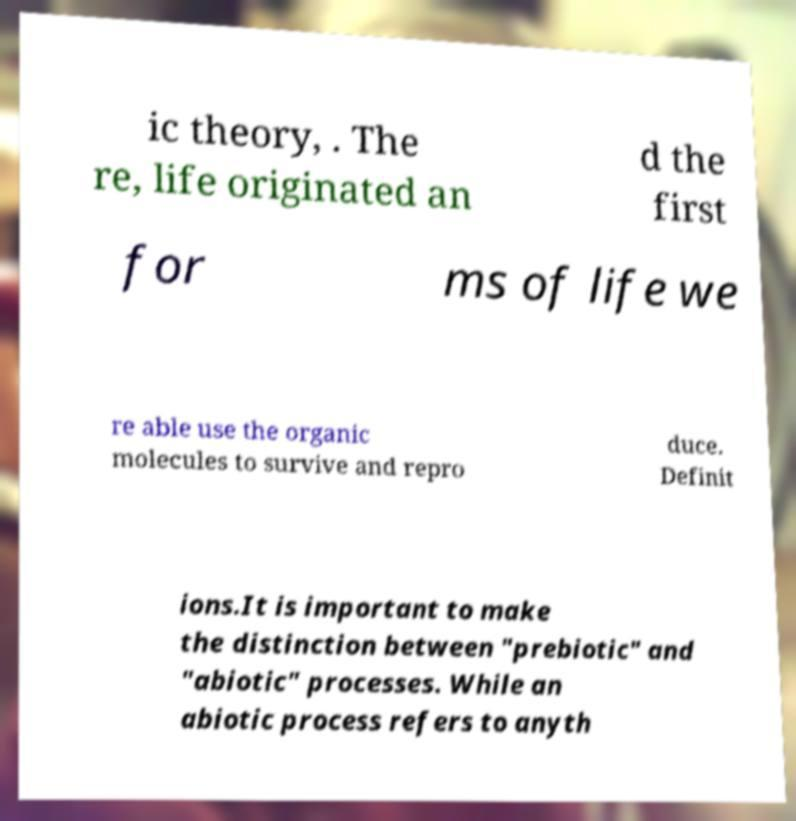I need the written content from this picture converted into text. Can you do that? ic theory, . The re, life originated an d the first for ms of life we re able use the organic molecules to survive and repro duce. Definit ions.It is important to make the distinction between "prebiotic" and "abiotic" processes. While an abiotic process refers to anyth 